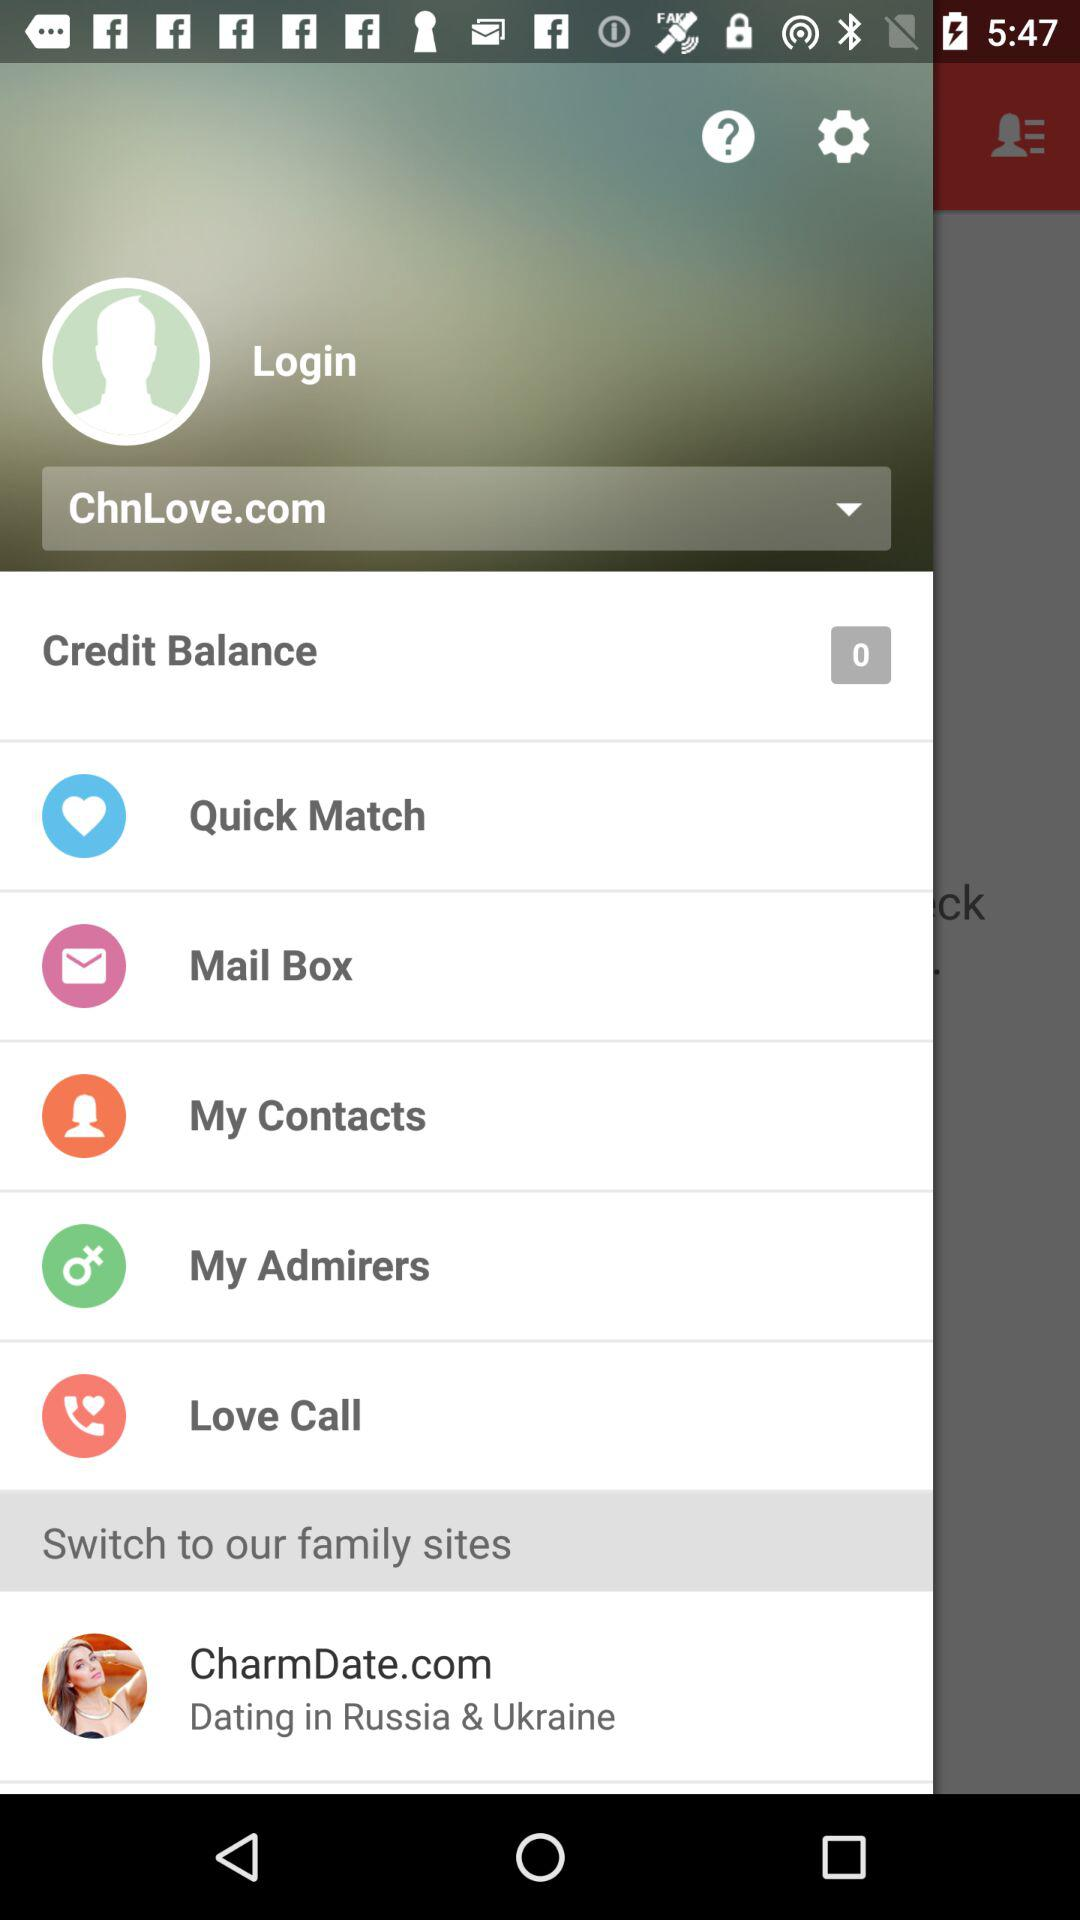What is the credit balance? The credit balance is 0. 